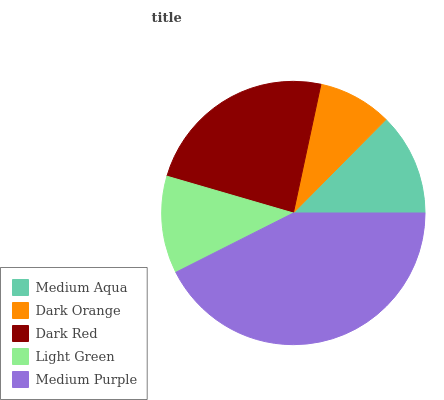Is Dark Orange the minimum?
Answer yes or no. Yes. Is Medium Purple the maximum?
Answer yes or no. Yes. Is Dark Red the minimum?
Answer yes or no. No. Is Dark Red the maximum?
Answer yes or no. No. Is Dark Red greater than Dark Orange?
Answer yes or no. Yes. Is Dark Orange less than Dark Red?
Answer yes or no. Yes. Is Dark Orange greater than Dark Red?
Answer yes or no. No. Is Dark Red less than Dark Orange?
Answer yes or no. No. Is Medium Aqua the high median?
Answer yes or no. Yes. Is Medium Aqua the low median?
Answer yes or no. Yes. Is Dark Red the high median?
Answer yes or no. No. Is Dark Red the low median?
Answer yes or no. No. 